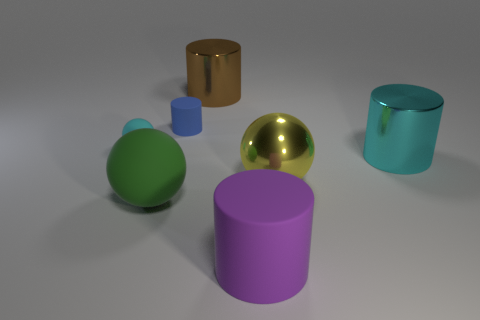Subtract all cylinders. How many objects are left? 3 Subtract 2 balls. How many balls are left? 1 Subtract all red cylinders. Subtract all cyan blocks. How many cylinders are left? 4 Subtract all purple spheres. How many blue cylinders are left? 1 Subtract all large red metallic spheres. Subtract all cyan matte things. How many objects are left? 6 Add 1 yellow metal spheres. How many yellow metal spheres are left? 2 Add 5 blue rubber things. How many blue rubber things exist? 6 Add 2 tiny matte cylinders. How many objects exist? 9 Subtract all brown cylinders. How many cylinders are left? 3 Subtract all big yellow metal balls. How many balls are left? 2 